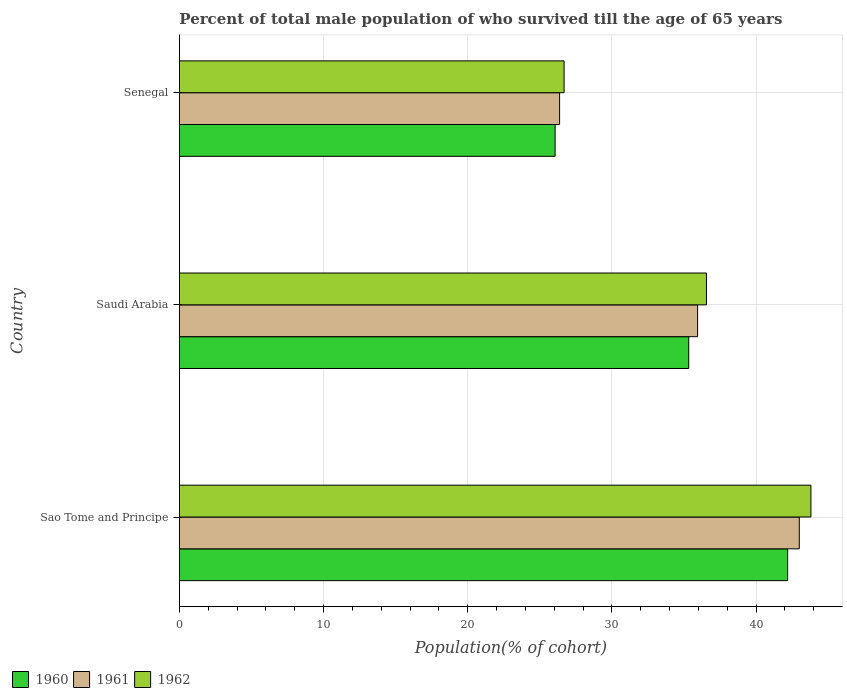How many bars are there on the 1st tick from the top?
Your answer should be compact. 3. What is the label of the 2nd group of bars from the top?
Your answer should be compact. Saudi Arabia. What is the percentage of total male population who survived till the age of 65 years in 1961 in Senegal?
Provide a short and direct response. 26.37. Across all countries, what is the maximum percentage of total male population who survived till the age of 65 years in 1962?
Offer a very short reply. 43.81. Across all countries, what is the minimum percentage of total male population who survived till the age of 65 years in 1960?
Ensure brevity in your answer.  26.06. In which country was the percentage of total male population who survived till the age of 65 years in 1961 maximum?
Your answer should be compact. Sao Tome and Principe. In which country was the percentage of total male population who survived till the age of 65 years in 1960 minimum?
Your answer should be compact. Senegal. What is the total percentage of total male population who survived till the age of 65 years in 1960 in the graph?
Ensure brevity in your answer.  103.59. What is the difference between the percentage of total male population who survived till the age of 65 years in 1960 in Sao Tome and Principe and that in Senegal?
Keep it short and to the point. 16.13. What is the difference between the percentage of total male population who survived till the age of 65 years in 1960 in Senegal and the percentage of total male population who survived till the age of 65 years in 1961 in Sao Tome and Principe?
Provide a short and direct response. -16.94. What is the average percentage of total male population who survived till the age of 65 years in 1962 per country?
Your answer should be compact. 35.69. What is the difference between the percentage of total male population who survived till the age of 65 years in 1961 and percentage of total male population who survived till the age of 65 years in 1960 in Sao Tome and Principe?
Your response must be concise. 0.81. In how many countries, is the percentage of total male population who survived till the age of 65 years in 1961 greater than 40 %?
Provide a succinct answer. 1. What is the ratio of the percentage of total male population who survived till the age of 65 years in 1962 in Sao Tome and Principe to that in Senegal?
Ensure brevity in your answer.  1.64. What is the difference between the highest and the second highest percentage of total male population who survived till the age of 65 years in 1962?
Make the answer very short. 7.25. What is the difference between the highest and the lowest percentage of total male population who survived till the age of 65 years in 1961?
Offer a terse response. 16.63. Is it the case that in every country, the sum of the percentage of total male population who survived till the age of 65 years in 1960 and percentage of total male population who survived till the age of 65 years in 1961 is greater than the percentage of total male population who survived till the age of 65 years in 1962?
Offer a very short reply. Yes. How many bars are there?
Offer a terse response. 9. Where does the legend appear in the graph?
Provide a short and direct response. Bottom left. How many legend labels are there?
Ensure brevity in your answer.  3. What is the title of the graph?
Your answer should be compact. Percent of total male population of who survived till the age of 65 years. Does "1977" appear as one of the legend labels in the graph?
Your answer should be very brief. No. What is the label or title of the X-axis?
Keep it short and to the point. Population(% of cohort). What is the label or title of the Y-axis?
Give a very brief answer. Country. What is the Population(% of cohort) of 1960 in Sao Tome and Principe?
Provide a short and direct response. 42.19. What is the Population(% of cohort) of 1961 in Sao Tome and Principe?
Your response must be concise. 43. What is the Population(% of cohort) of 1962 in Sao Tome and Principe?
Your answer should be very brief. 43.81. What is the Population(% of cohort) of 1960 in Saudi Arabia?
Your response must be concise. 35.33. What is the Population(% of cohort) of 1961 in Saudi Arabia?
Your answer should be very brief. 35.95. What is the Population(% of cohort) in 1962 in Saudi Arabia?
Your answer should be very brief. 36.56. What is the Population(% of cohort) of 1960 in Senegal?
Offer a terse response. 26.06. What is the Population(% of cohort) in 1961 in Senegal?
Keep it short and to the point. 26.37. What is the Population(% of cohort) of 1962 in Senegal?
Provide a succinct answer. 26.69. Across all countries, what is the maximum Population(% of cohort) of 1960?
Give a very brief answer. 42.19. Across all countries, what is the maximum Population(% of cohort) in 1961?
Your response must be concise. 43. Across all countries, what is the maximum Population(% of cohort) of 1962?
Make the answer very short. 43.81. Across all countries, what is the minimum Population(% of cohort) in 1960?
Provide a short and direct response. 26.06. Across all countries, what is the minimum Population(% of cohort) of 1961?
Keep it short and to the point. 26.37. Across all countries, what is the minimum Population(% of cohort) of 1962?
Provide a succinct answer. 26.69. What is the total Population(% of cohort) in 1960 in the graph?
Your answer should be compact. 103.59. What is the total Population(% of cohort) in 1961 in the graph?
Make the answer very short. 105.32. What is the total Population(% of cohort) of 1962 in the graph?
Keep it short and to the point. 107.06. What is the difference between the Population(% of cohort) of 1960 in Sao Tome and Principe and that in Saudi Arabia?
Ensure brevity in your answer.  6.86. What is the difference between the Population(% of cohort) in 1961 in Sao Tome and Principe and that in Saudi Arabia?
Offer a very short reply. 7.05. What is the difference between the Population(% of cohort) in 1962 in Sao Tome and Principe and that in Saudi Arabia?
Give a very brief answer. 7.25. What is the difference between the Population(% of cohort) in 1960 in Sao Tome and Principe and that in Senegal?
Keep it short and to the point. 16.13. What is the difference between the Population(% of cohort) in 1961 in Sao Tome and Principe and that in Senegal?
Your response must be concise. 16.63. What is the difference between the Population(% of cohort) of 1962 in Sao Tome and Principe and that in Senegal?
Make the answer very short. 17.12. What is the difference between the Population(% of cohort) of 1960 in Saudi Arabia and that in Senegal?
Keep it short and to the point. 9.27. What is the difference between the Population(% of cohort) of 1961 in Saudi Arabia and that in Senegal?
Make the answer very short. 9.57. What is the difference between the Population(% of cohort) of 1962 in Saudi Arabia and that in Senegal?
Your answer should be compact. 9.88. What is the difference between the Population(% of cohort) of 1960 in Sao Tome and Principe and the Population(% of cohort) of 1961 in Saudi Arabia?
Make the answer very short. 6.25. What is the difference between the Population(% of cohort) in 1960 in Sao Tome and Principe and the Population(% of cohort) in 1962 in Saudi Arabia?
Keep it short and to the point. 5.63. What is the difference between the Population(% of cohort) of 1961 in Sao Tome and Principe and the Population(% of cohort) of 1962 in Saudi Arabia?
Your answer should be very brief. 6.44. What is the difference between the Population(% of cohort) in 1960 in Sao Tome and Principe and the Population(% of cohort) in 1961 in Senegal?
Provide a short and direct response. 15.82. What is the difference between the Population(% of cohort) of 1960 in Sao Tome and Principe and the Population(% of cohort) of 1962 in Senegal?
Offer a very short reply. 15.51. What is the difference between the Population(% of cohort) in 1961 in Sao Tome and Principe and the Population(% of cohort) in 1962 in Senegal?
Keep it short and to the point. 16.32. What is the difference between the Population(% of cohort) of 1960 in Saudi Arabia and the Population(% of cohort) of 1961 in Senegal?
Make the answer very short. 8.96. What is the difference between the Population(% of cohort) of 1960 in Saudi Arabia and the Population(% of cohort) of 1962 in Senegal?
Your response must be concise. 8.65. What is the difference between the Population(% of cohort) in 1961 in Saudi Arabia and the Population(% of cohort) in 1962 in Senegal?
Offer a terse response. 9.26. What is the average Population(% of cohort) in 1960 per country?
Offer a very short reply. 34.53. What is the average Population(% of cohort) of 1961 per country?
Give a very brief answer. 35.11. What is the average Population(% of cohort) in 1962 per country?
Offer a very short reply. 35.69. What is the difference between the Population(% of cohort) of 1960 and Population(% of cohort) of 1961 in Sao Tome and Principe?
Provide a short and direct response. -0.81. What is the difference between the Population(% of cohort) of 1960 and Population(% of cohort) of 1962 in Sao Tome and Principe?
Keep it short and to the point. -1.62. What is the difference between the Population(% of cohort) in 1961 and Population(% of cohort) in 1962 in Sao Tome and Principe?
Keep it short and to the point. -0.81. What is the difference between the Population(% of cohort) in 1960 and Population(% of cohort) in 1961 in Saudi Arabia?
Make the answer very short. -0.61. What is the difference between the Population(% of cohort) of 1960 and Population(% of cohort) of 1962 in Saudi Arabia?
Make the answer very short. -1.23. What is the difference between the Population(% of cohort) of 1961 and Population(% of cohort) of 1962 in Saudi Arabia?
Provide a short and direct response. -0.61. What is the difference between the Population(% of cohort) of 1960 and Population(% of cohort) of 1961 in Senegal?
Offer a terse response. -0.31. What is the difference between the Population(% of cohort) of 1960 and Population(% of cohort) of 1962 in Senegal?
Your answer should be very brief. -0.62. What is the difference between the Population(% of cohort) in 1961 and Population(% of cohort) in 1962 in Senegal?
Your answer should be very brief. -0.31. What is the ratio of the Population(% of cohort) in 1960 in Sao Tome and Principe to that in Saudi Arabia?
Offer a very short reply. 1.19. What is the ratio of the Population(% of cohort) in 1961 in Sao Tome and Principe to that in Saudi Arabia?
Give a very brief answer. 1.2. What is the ratio of the Population(% of cohort) in 1962 in Sao Tome and Principe to that in Saudi Arabia?
Provide a short and direct response. 1.2. What is the ratio of the Population(% of cohort) of 1960 in Sao Tome and Principe to that in Senegal?
Give a very brief answer. 1.62. What is the ratio of the Population(% of cohort) in 1961 in Sao Tome and Principe to that in Senegal?
Your response must be concise. 1.63. What is the ratio of the Population(% of cohort) of 1962 in Sao Tome and Principe to that in Senegal?
Give a very brief answer. 1.64. What is the ratio of the Population(% of cohort) in 1960 in Saudi Arabia to that in Senegal?
Provide a short and direct response. 1.36. What is the ratio of the Population(% of cohort) in 1961 in Saudi Arabia to that in Senegal?
Your answer should be very brief. 1.36. What is the ratio of the Population(% of cohort) of 1962 in Saudi Arabia to that in Senegal?
Offer a terse response. 1.37. What is the difference between the highest and the second highest Population(% of cohort) in 1960?
Offer a terse response. 6.86. What is the difference between the highest and the second highest Population(% of cohort) in 1961?
Your answer should be very brief. 7.05. What is the difference between the highest and the second highest Population(% of cohort) in 1962?
Keep it short and to the point. 7.25. What is the difference between the highest and the lowest Population(% of cohort) of 1960?
Your answer should be very brief. 16.13. What is the difference between the highest and the lowest Population(% of cohort) of 1961?
Keep it short and to the point. 16.63. What is the difference between the highest and the lowest Population(% of cohort) in 1962?
Provide a succinct answer. 17.12. 